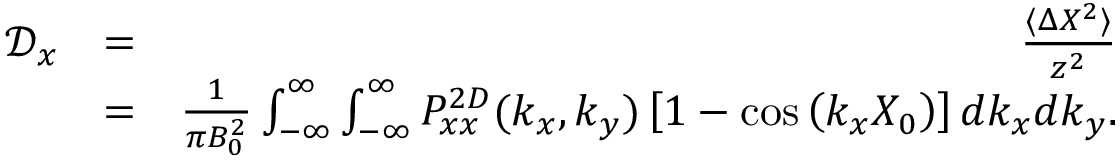<formula> <loc_0><loc_0><loc_500><loc_500>\begin{array} { r l r } { \mathcal { D } _ { x } } & { = } & { \frac { \langle \Delta X ^ { 2 } \rangle } { z ^ { 2 } } } \\ & { = } & { \frac { 1 } { \pi B _ { 0 } ^ { 2 } } \int _ { - \infty } ^ { \infty } \int _ { - \infty } ^ { \infty } P _ { x x } ^ { 2 D } ( k _ { x } , k _ { y } ) \left [ 1 - \cos \left ( k _ { x } X _ { 0 } \right ) \right ] d k _ { x } d k _ { y } . } \end{array}</formula> 